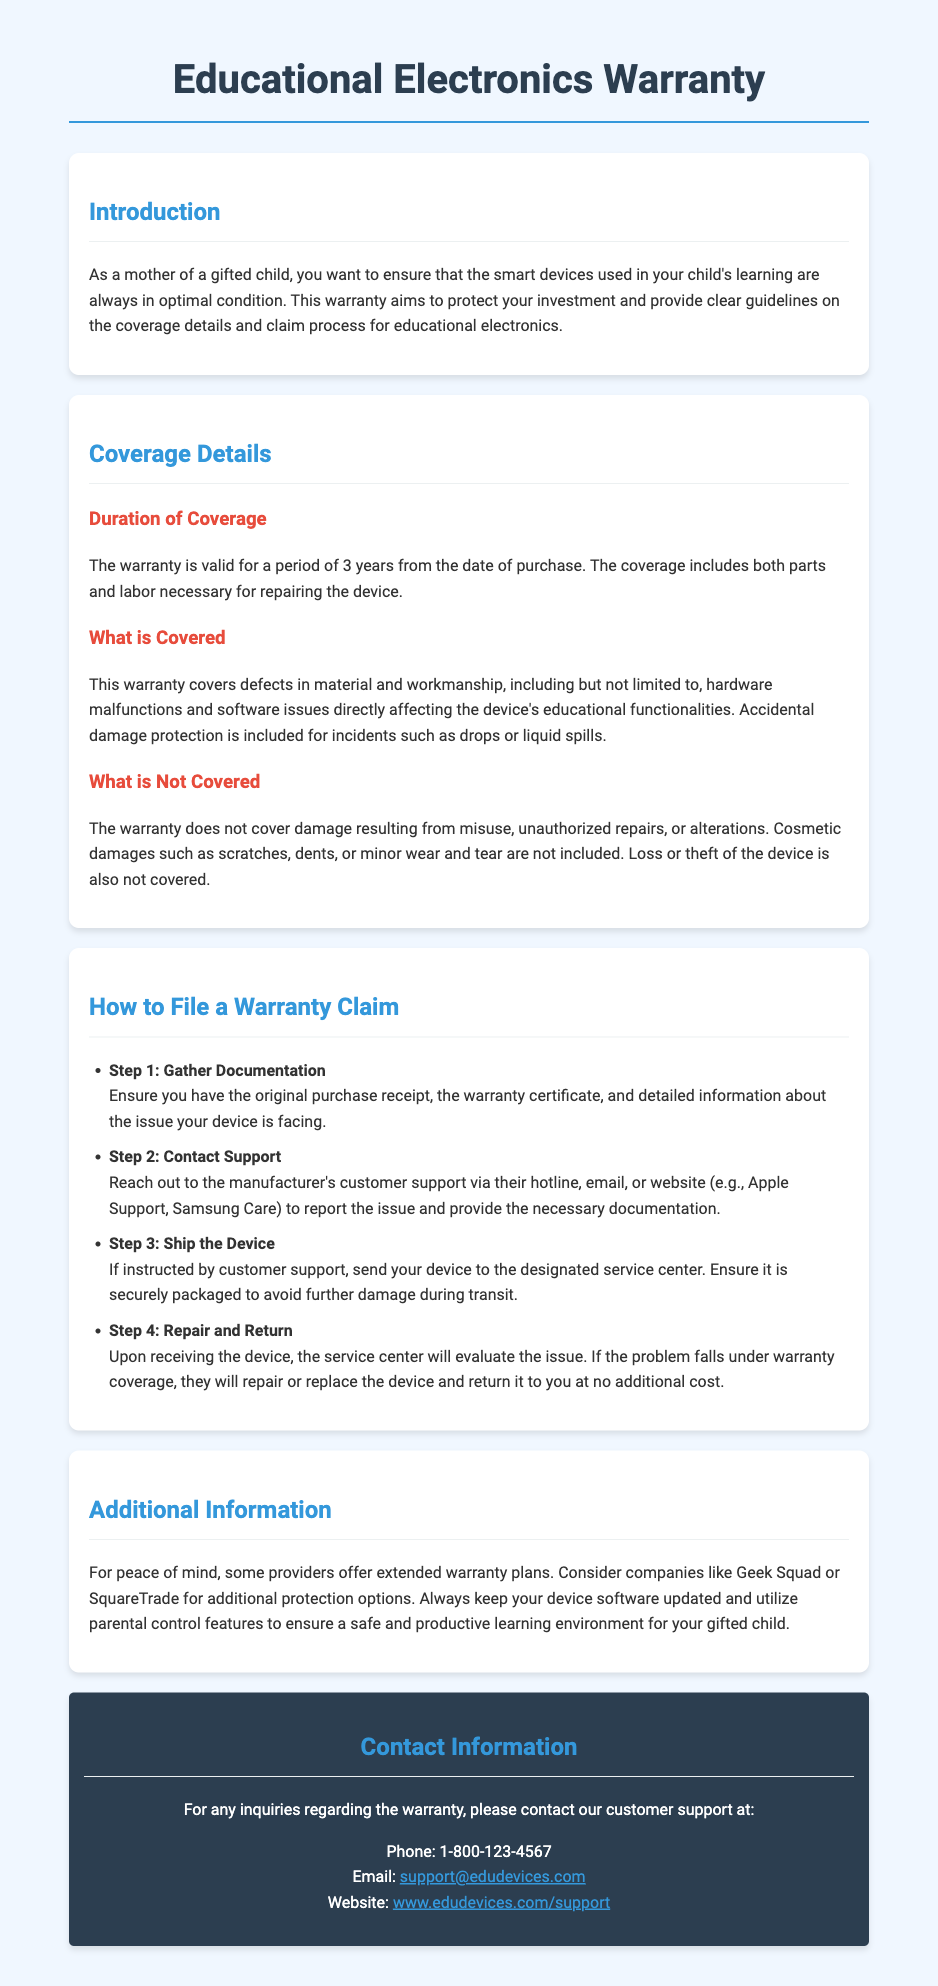What is the duration of warranty coverage? The warranty is valid for a period of 3 years from the date of purchase.
Answer: 3 years What types of damage are covered? The warranty covers defects in material and workmanship, hardware malfunctions, software issues, and accidental damage.
Answer: Hardware malfunctions and software issues What is explicitly not covered by the warranty? The warranty does not cover damage resulting from misuse, unauthorized repairs, cosmetic damages, loss, or theft.
Answer: Misuse What is the first step in filing a warranty claim? Step 1 in the claim process requires gathering the original purchase receipt, warranty certificate, and issue details.
Answer: Gather Documentation How can you contact customer support? Customer support can be reached via phone, email, or their website.
Answer: Phone, email, website What kind of additional protection options are mentioned? The document mentions extended warranty plans offered by companies like Geek Squad or SquareTrade.
Answer: Extended warranty plans What type of damages are not included in the warranty? Cosmetic damages such as scratches, dents, or minor wear and tear are not included.
Answer: Cosmetic damages What is the claim process step after contacting support? After contacting support, the next step is to ship the device if instructed.
Answer: Ship the Device Who should you contact for inquiries regarding the warranty? For inquiries regarding the warranty, the customer support contact details are provided in the document.
Answer: Customer support 